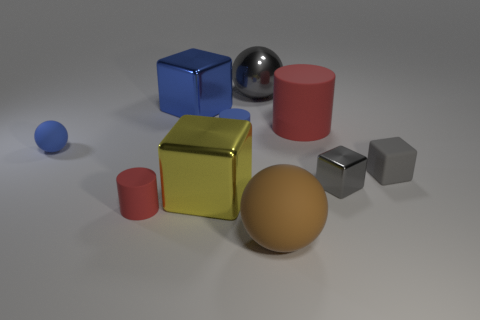Subtract all big gray metal spheres. How many spheres are left? 2 Subtract all yellow cubes. How many cubes are left? 3 Subtract 2 cylinders. How many cylinders are left? 1 Subtract all cyan cylinders. How many gray spheres are left? 1 Subtract 0 purple cubes. How many objects are left? 10 Subtract all cylinders. How many objects are left? 7 Subtract all cyan balls. Subtract all cyan cubes. How many balls are left? 3 Subtract all yellow objects. Subtract all small gray objects. How many objects are left? 7 Add 2 blue objects. How many blue objects are left? 5 Add 1 gray metal blocks. How many gray metal blocks exist? 2 